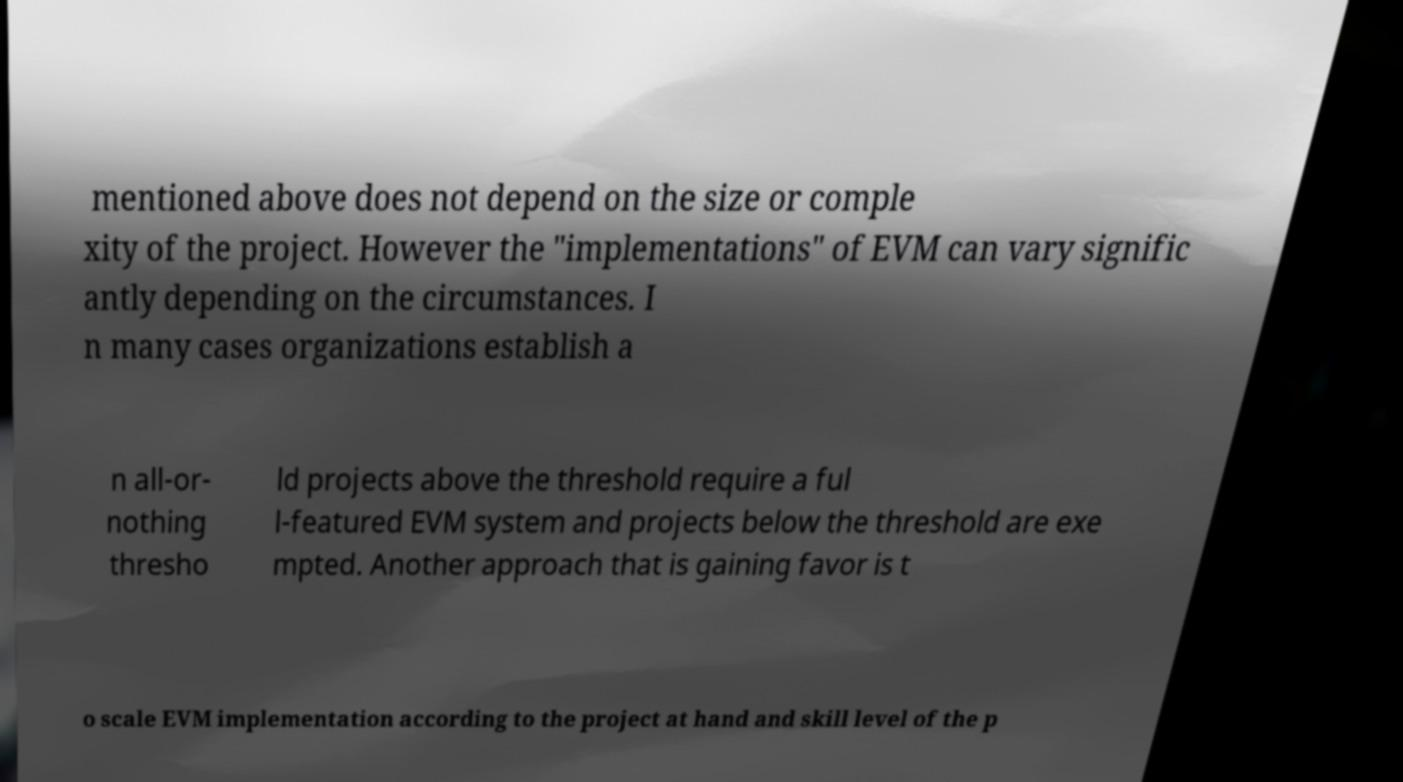Could you extract and type out the text from this image? mentioned above does not depend on the size or comple xity of the project. However the "implementations" of EVM can vary signific antly depending on the circumstances. I n many cases organizations establish a n all-or- nothing thresho ld projects above the threshold require a ful l-featured EVM system and projects below the threshold are exe mpted. Another approach that is gaining favor is t o scale EVM implementation according to the project at hand and skill level of the p 